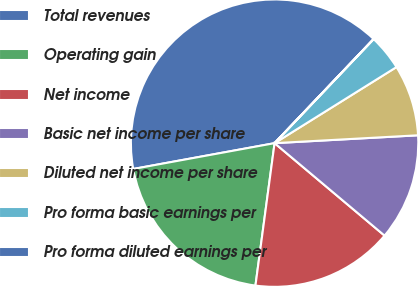Convert chart. <chart><loc_0><loc_0><loc_500><loc_500><pie_chart><fcel>Total revenues<fcel>Operating gain<fcel>Net income<fcel>Basic net income per share<fcel>Diluted net income per share<fcel>Pro forma basic earnings per<fcel>Pro forma diluted earnings per<nl><fcel>39.98%<fcel>20.0%<fcel>16.0%<fcel>12.0%<fcel>8.01%<fcel>4.01%<fcel>0.01%<nl></chart> 